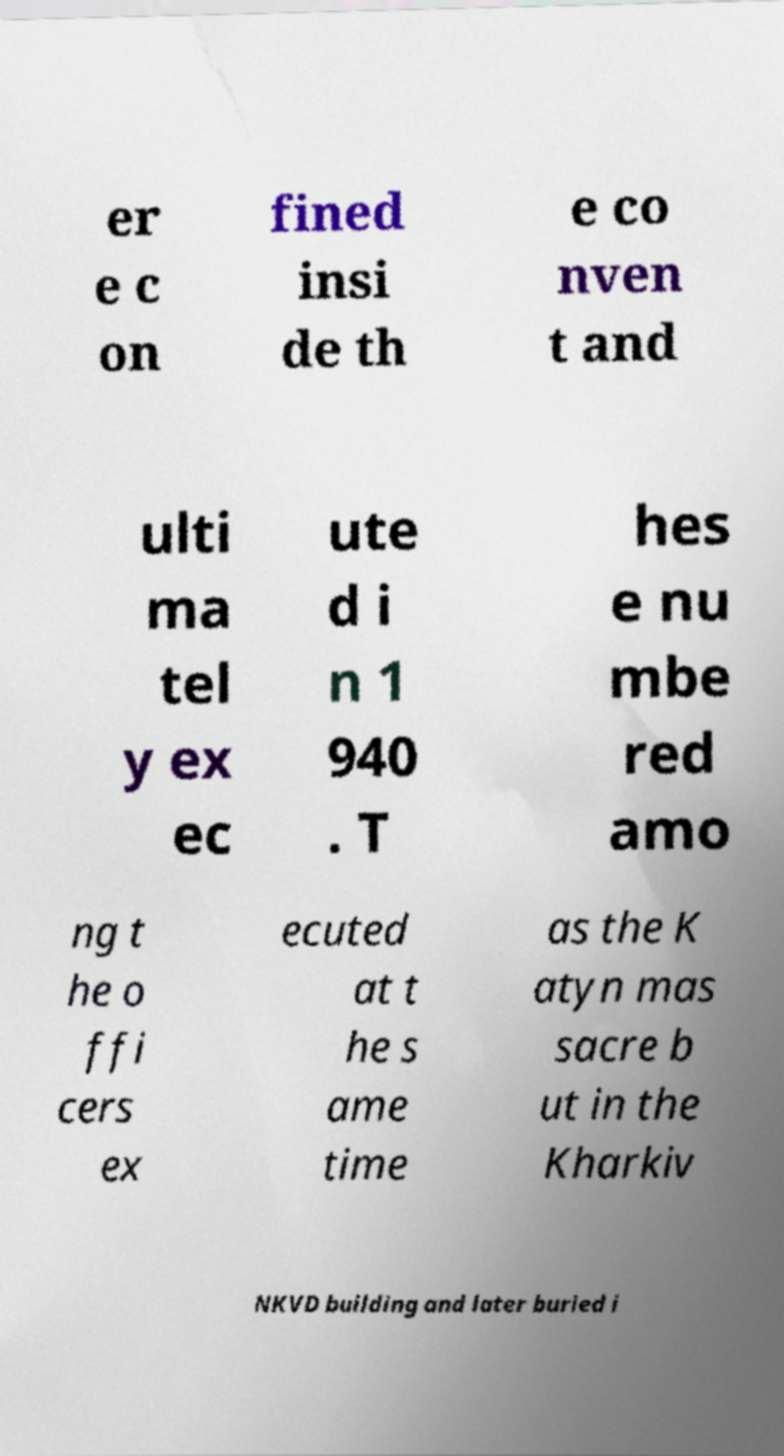There's text embedded in this image that I need extracted. Can you transcribe it verbatim? er e c on fined insi de th e co nven t and ulti ma tel y ex ec ute d i n 1 940 . T hes e nu mbe red amo ng t he o ffi cers ex ecuted at t he s ame time as the K atyn mas sacre b ut in the Kharkiv NKVD building and later buried i 